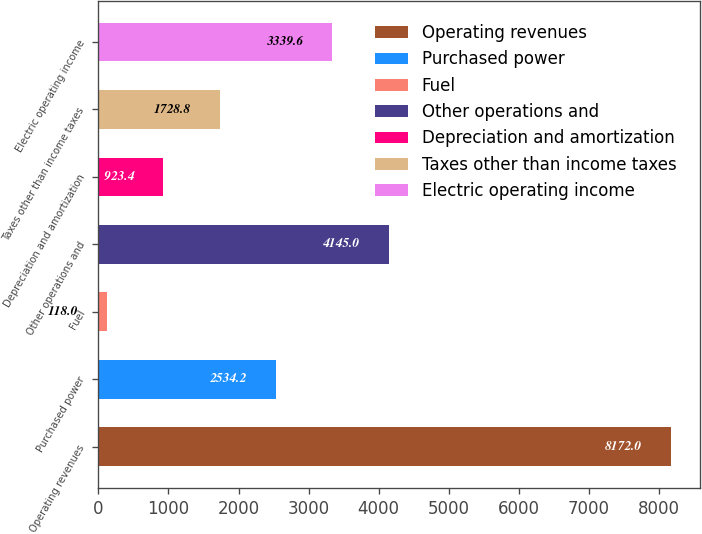<chart> <loc_0><loc_0><loc_500><loc_500><bar_chart><fcel>Operating revenues<fcel>Purchased power<fcel>Fuel<fcel>Other operations and<fcel>Depreciation and amortization<fcel>Taxes other than income taxes<fcel>Electric operating income<nl><fcel>8172<fcel>2534.2<fcel>118<fcel>4145<fcel>923.4<fcel>1728.8<fcel>3339.6<nl></chart> 